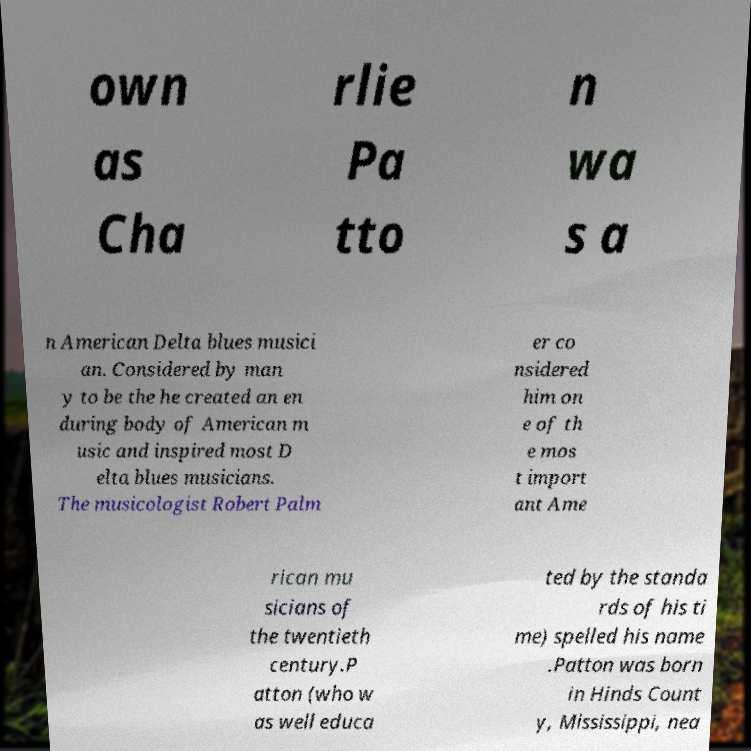Could you assist in decoding the text presented in this image and type it out clearly? own as Cha rlie Pa tto n wa s a n American Delta blues musici an. Considered by man y to be the he created an en during body of American m usic and inspired most D elta blues musicians. The musicologist Robert Palm er co nsidered him on e of th e mos t import ant Ame rican mu sicians of the twentieth century.P atton (who w as well educa ted by the standa rds of his ti me) spelled his name .Patton was born in Hinds Count y, Mississippi, nea 